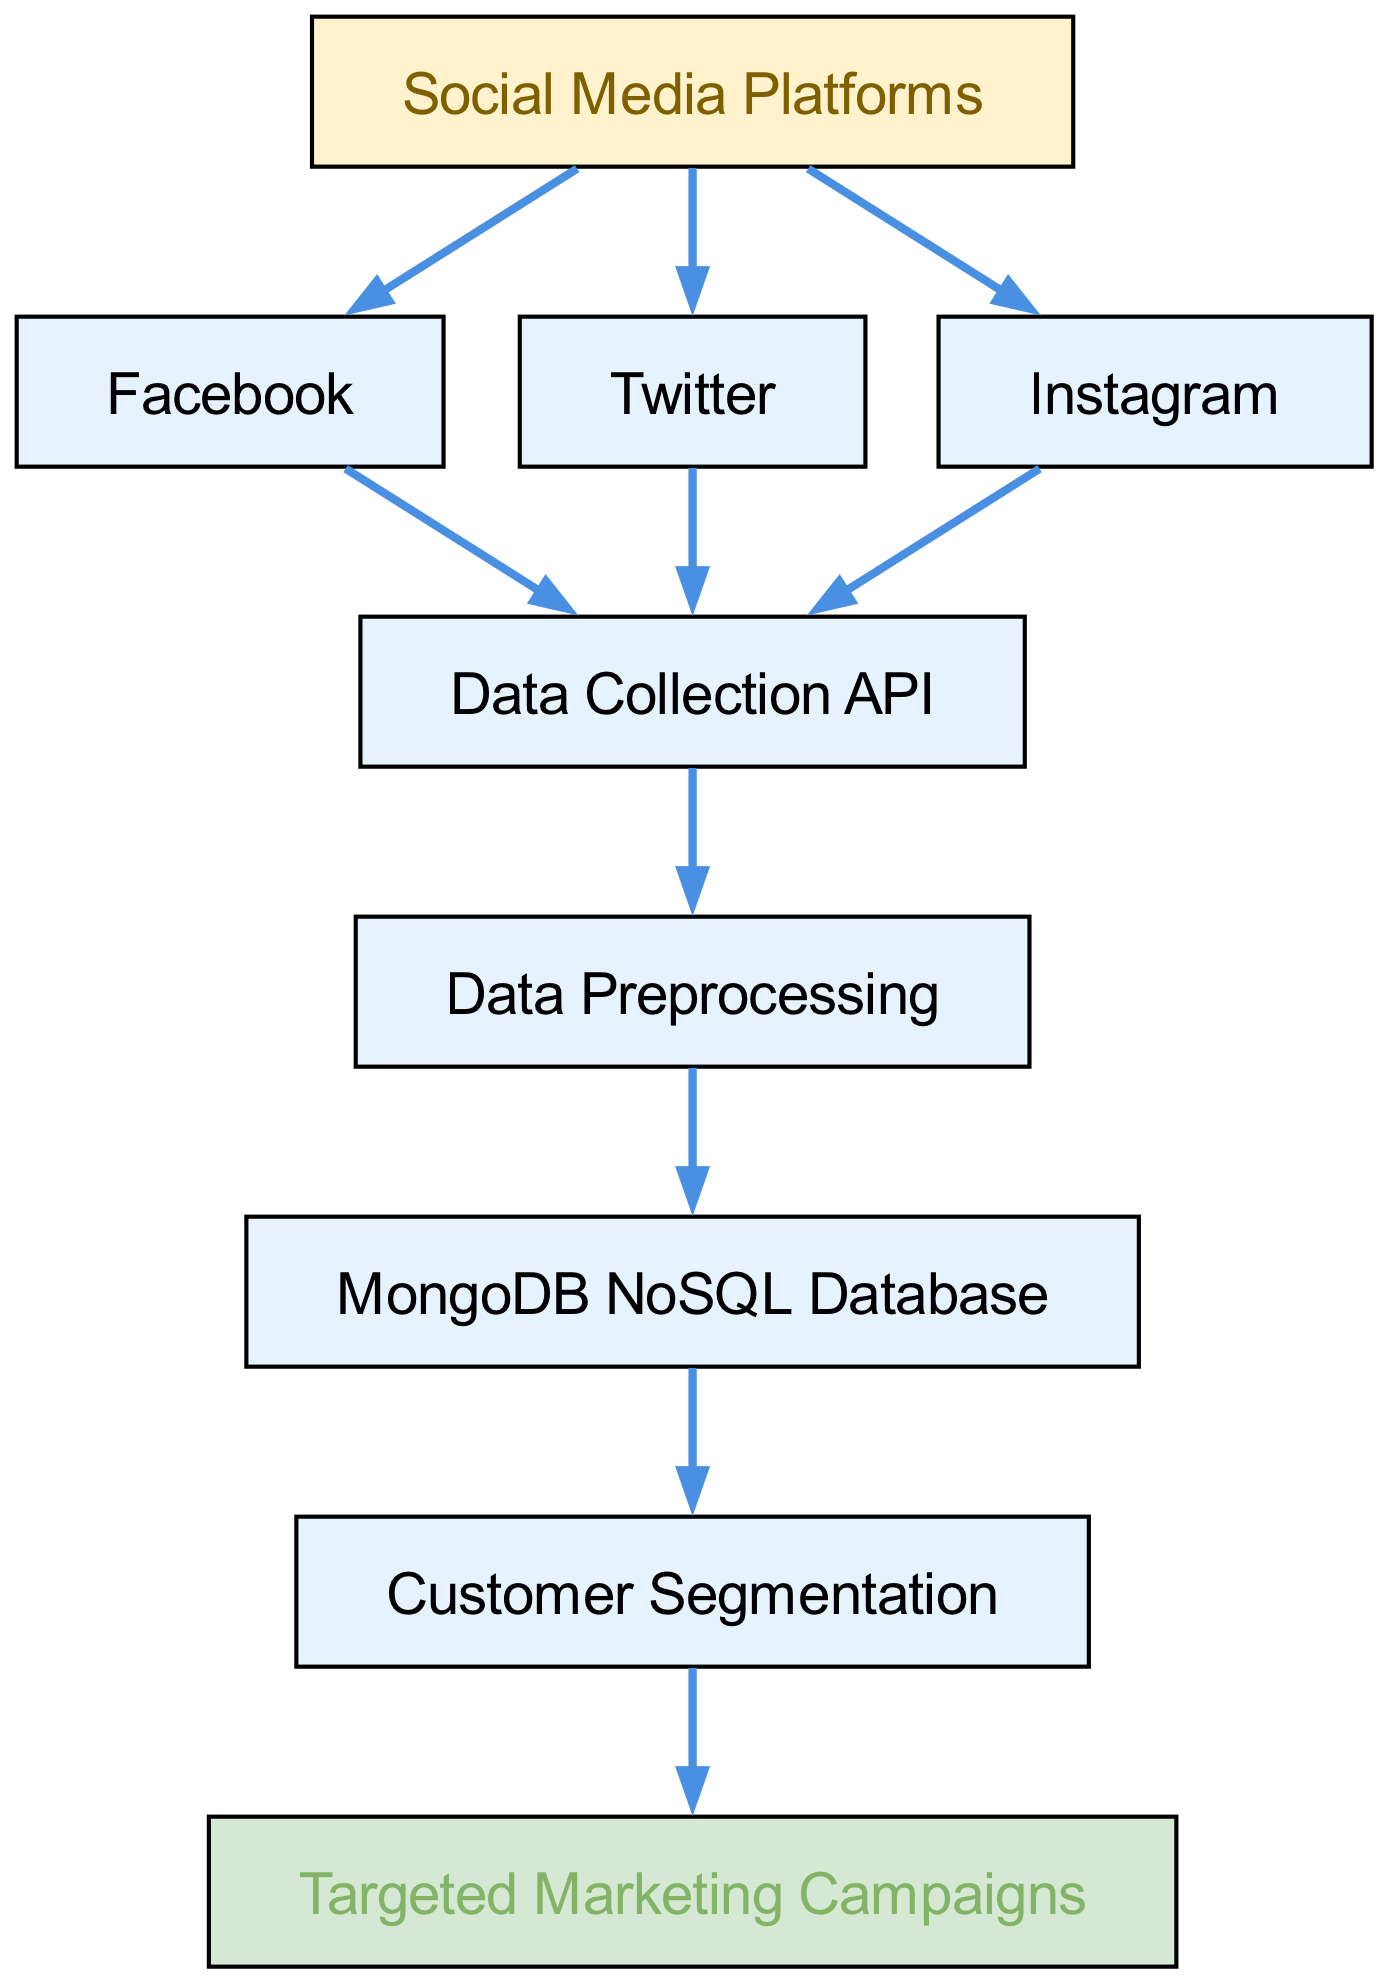What is the first element in the customer data flow? The first element is "Social Media Platforms," which indicates the starting point for collecting customer data for targeted marketing campaigns.
Answer: Social Media Platforms How many social media platforms are included in the flow? There are three social media platforms connected to the "Social Media Platforms" node: Facebook, Twitter, and Instagram, which are significant sources of customer data.
Answer: Three What node follows the "Data Collection API"? "Data Preprocessing" is the node that follows "Data Collection API," indicating that after data is collected, it is processed before being stored in the database.
Answer: Data Preprocessing Which database is used to store customer data? The customer data is stored in the "MongoDB NoSQL Database," which allows for flexible handling of various data types and structures.
Answer: MongoDB NoSQL Database How many steps are there from "Social Media Platforms" to "Targeted Marketing Campaigns"? There are five steps in total, taking the path from "Social Media Platforms" to "Targeted Marketing Campaigns" through the connected nodes: "Data Collection API," "Data Preprocessing," "MongoDB NoSQL Database," and "Customer Segmentation."
Answer: Five What is the relationship between "Customer Segmentation" and "Targeted Marketing Campaigns"? "Customer Segmentation" precedes "Targeted Marketing Campaigns," meaning that customer groups are defined before executing marketing strategies aimed at them.
Answer: Precedes What type of database is represented in the diagram? The diagram represents a NoSQL database, specifically highlighted as MongoDB, which supports unstructured and semi-structured data storage for customer information.
Answer: NoSQL What is the last step in the customer data flow? The last step is "Targeted Marketing Campaigns," which signifies the culmination of the process by utilizing segmented customer data for specific marketing efforts.
Answer: Targeted Marketing Campaigns 